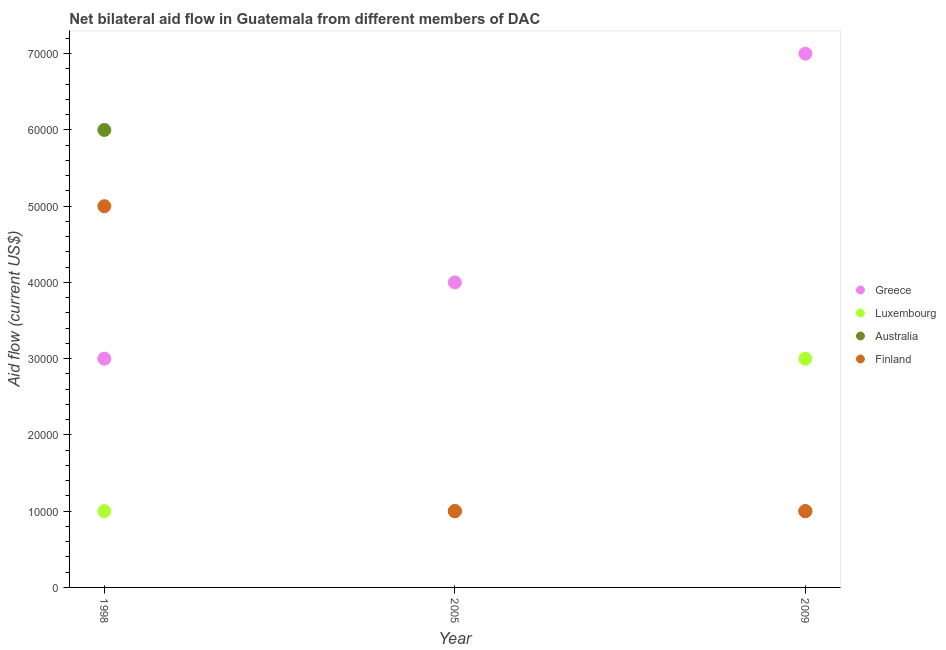What is the amount of aid given by luxembourg in 2005?
Make the answer very short. 10000. Across all years, what is the maximum amount of aid given by greece?
Keep it short and to the point. 7.00e+04. Across all years, what is the minimum amount of aid given by greece?
Provide a succinct answer. 3.00e+04. In which year was the amount of aid given by australia maximum?
Provide a succinct answer. 1998. What is the total amount of aid given by luxembourg in the graph?
Offer a terse response. 5.00e+04. What is the difference between the amount of aid given by australia in 1998 and the amount of aid given by finland in 2009?
Offer a very short reply. 5.00e+04. What is the average amount of aid given by luxembourg per year?
Your answer should be very brief. 1.67e+04. In the year 2009, what is the difference between the amount of aid given by greece and amount of aid given by finland?
Keep it short and to the point. 6.00e+04. In how many years, is the amount of aid given by australia greater than 10000 US$?
Your answer should be compact. 1. Is the difference between the amount of aid given by luxembourg in 1998 and 2009 greater than the difference between the amount of aid given by finland in 1998 and 2009?
Provide a succinct answer. No. What is the difference between the highest and the lowest amount of aid given by australia?
Offer a terse response. 5.00e+04. Is the sum of the amount of aid given by luxembourg in 2005 and 2009 greater than the maximum amount of aid given by australia across all years?
Make the answer very short. No. How many years are there in the graph?
Give a very brief answer. 3. Does the graph contain any zero values?
Your answer should be compact. No. Does the graph contain grids?
Your answer should be very brief. No. How many legend labels are there?
Offer a terse response. 4. How are the legend labels stacked?
Ensure brevity in your answer.  Vertical. What is the title of the graph?
Keep it short and to the point. Net bilateral aid flow in Guatemala from different members of DAC. What is the label or title of the Y-axis?
Provide a short and direct response. Aid flow (current US$). What is the Aid flow (current US$) in Greece in 1998?
Make the answer very short. 3.00e+04. What is the Aid flow (current US$) of Finland in 1998?
Your answer should be very brief. 5.00e+04. What is the Aid flow (current US$) of Greece in 2005?
Provide a succinct answer. 4.00e+04. What is the Aid flow (current US$) in Australia in 2005?
Offer a terse response. 10000. What is the Aid flow (current US$) of Finland in 2005?
Your answer should be compact. 10000. What is the Aid flow (current US$) of Greece in 2009?
Provide a short and direct response. 7.00e+04. What is the Aid flow (current US$) in Australia in 2009?
Ensure brevity in your answer.  10000. What is the Aid flow (current US$) of Finland in 2009?
Make the answer very short. 10000. Across all years, what is the maximum Aid flow (current US$) in Luxembourg?
Your response must be concise. 3.00e+04. Across all years, what is the maximum Aid flow (current US$) of Australia?
Make the answer very short. 6.00e+04. Across all years, what is the minimum Aid flow (current US$) in Luxembourg?
Your response must be concise. 10000. What is the total Aid flow (current US$) of Greece in the graph?
Offer a terse response. 1.40e+05. What is the total Aid flow (current US$) in Luxembourg in the graph?
Your response must be concise. 5.00e+04. What is the total Aid flow (current US$) in Australia in the graph?
Your answer should be compact. 8.00e+04. What is the total Aid flow (current US$) in Finland in the graph?
Your response must be concise. 7.00e+04. What is the difference between the Aid flow (current US$) in Luxembourg in 1998 and that in 2005?
Provide a succinct answer. 0. What is the difference between the Aid flow (current US$) in Finland in 1998 and that in 2005?
Make the answer very short. 4.00e+04. What is the difference between the Aid flow (current US$) of Greece in 1998 and that in 2009?
Your response must be concise. -4.00e+04. What is the difference between the Aid flow (current US$) of Luxembourg in 1998 and that in 2009?
Your response must be concise. -2.00e+04. What is the difference between the Aid flow (current US$) of Australia in 1998 and that in 2009?
Your answer should be very brief. 5.00e+04. What is the difference between the Aid flow (current US$) of Greece in 2005 and that in 2009?
Your answer should be compact. -3.00e+04. What is the difference between the Aid flow (current US$) of Luxembourg in 2005 and that in 2009?
Your answer should be very brief. -2.00e+04. What is the difference between the Aid flow (current US$) of Australia in 2005 and that in 2009?
Your answer should be very brief. 0. What is the difference between the Aid flow (current US$) in Finland in 2005 and that in 2009?
Provide a short and direct response. 0. What is the difference between the Aid flow (current US$) in Greece in 1998 and the Aid flow (current US$) in Finland in 2005?
Make the answer very short. 2.00e+04. What is the difference between the Aid flow (current US$) of Luxembourg in 1998 and the Aid flow (current US$) of Finland in 2005?
Ensure brevity in your answer.  0. What is the difference between the Aid flow (current US$) in Greece in 1998 and the Aid flow (current US$) in Australia in 2009?
Your answer should be very brief. 2.00e+04. What is the difference between the Aid flow (current US$) of Luxembourg in 1998 and the Aid flow (current US$) of Finland in 2009?
Provide a short and direct response. 0. What is the difference between the Aid flow (current US$) of Luxembourg in 2005 and the Aid flow (current US$) of Australia in 2009?
Your answer should be very brief. 0. What is the difference between the Aid flow (current US$) of Australia in 2005 and the Aid flow (current US$) of Finland in 2009?
Your answer should be very brief. 0. What is the average Aid flow (current US$) in Greece per year?
Your answer should be very brief. 4.67e+04. What is the average Aid flow (current US$) in Luxembourg per year?
Your response must be concise. 1.67e+04. What is the average Aid flow (current US$) of Australia per year?
Offer a terse response. 2.67e+04. What is the average Aid flow (current US$) in Finland per year?
Give a very brief answer. 2.33e+04. In the year 1998, what is the difference between the Aid flow (current US$) of Greece and Aid flow (current US$) of Finland?
Keep it short and to the point. -2.00e+04. In the year 1998, what is the difference between the Aid flow (current US$) in Luxembourg and Aid flow (current US$) in Australia?
Offer a terse response. -5.00e+04. In the year 1998, what is the difference between the Aid flow (current US$) in Australia and Aid flow (current US$) in Finland?
Ensure brevity in your answer.  10000. In the year 2005, what is the difference between the Aid flow (current US$) in Greece and Aid flow (current US$) in Luxembourg?
Provide a succinct answer. 3.00e+04. In the year 2005, what is the difference between the Aid flow (current US$) of Greece and Aid flow (current US$) of Finland?
Offer a very short reply. 3.00e+04. In the year 2005, what is the difference between the Aid flow (current US$) of Luxembourg and Aid flow (current US$) of Finland?
Your response must be concise. 0. In the year 2005, what is the difference between the Aid flow (current US$) of Australia and Aid flow (current US$) of Finland?
Provide a succinct answer. 0. In the year 2009, what is the difference between the Aid flow (current US$) in Greece and Aid flow (current US$) in Luxembourg?
Your response must be concise. 4.00e+04. In the year 2009, what is the difference between the Aid flow (current US$) in Luxembourg and Aid flow (current US$) in Australia?
Make the answer very short. 2.00e+04. In the year 2009, what is the difference between the Aid flow (current US$) of Luxembourg and Aid flow (current US$) of Finland?
Offer a very short reply. 2.00e+04. What is the ratio of the Aid flow (current US$) of Luxembourg in 1998 to that in 2005?
Keep it short and to the point. 1. What is the ratio of the Aid flow (current US$) in Greece in 1998 to that in 2009?
Offer a terse response. 0.43. What is the ratio of the Aid flow (current US$) of Luxembourg in 1998 to that in 2009?
Offer a terse response. 0.33. What is the ratio of the Aid flow (current US$) in Australia in 1998 to that in 2009?
Your answer should be compact. 6. What is the ratio of the Aid flow (current US$) in Finland in 1998 to that in 2009?
Your answer should be compact. 5. What is the ratio of the Aid flow (current US$) in Greece in 2005 to that in 2009?
Your answer should be compact. 0.57. What is the ratio of the Aid flow (current US$) in Finland in 2005 to that in 2009?
Your response must be concise. 1. What is the difference between the highest and the second highest Aid flow (current US$) in Greece?
Ensure brevity in your answer.  3.00e+04. What is the difference between the highest and the second highest Aid flow (current US$) in Australia?
Keep it short and to the point. 5.00e+04. What is the difference between the highest and the second highest Aid flow (current US$) of Finland?
Offer a terse response. 4.00e+04. What is the difference between the highest and the lowest Aid flow (current US$) of Greece?
Offer a terse response. 4.00e+04. What is the difference between the highest and the lowest Aid flow (current US$) of Australia?
Give a very brief answer. 5.00e+04. What is the difference between the highest and the lowest Aid flow (current US$) of Finland?
Your response must be concise. 4.00e+04. 